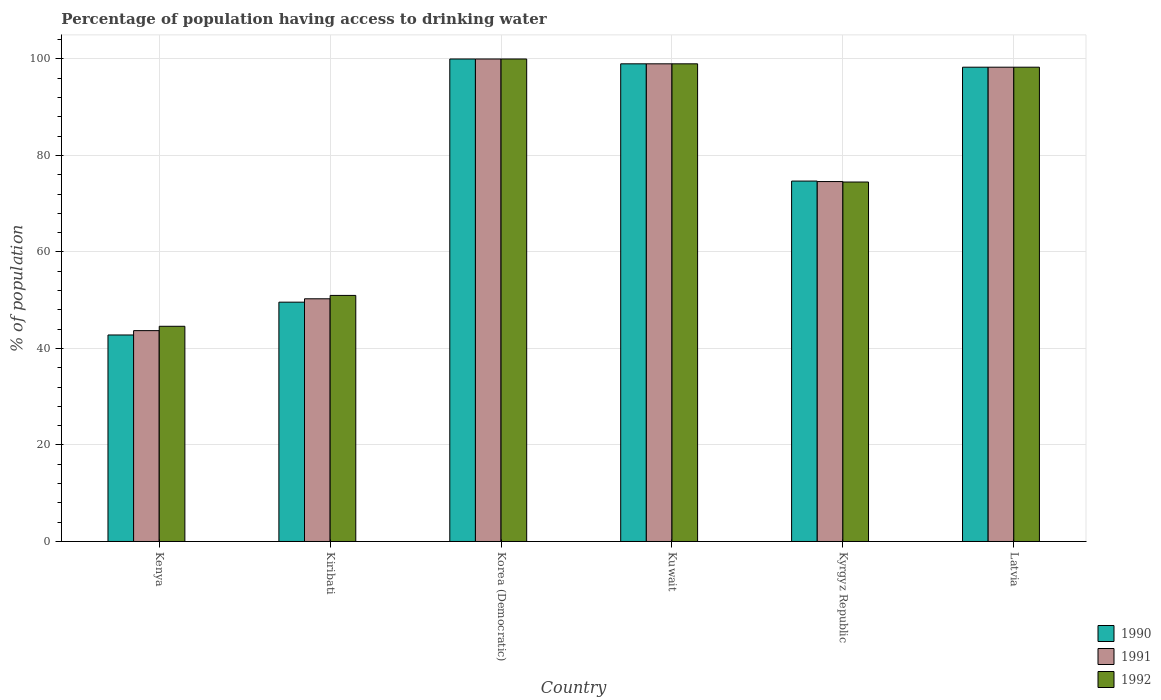How many different coloured bars are there?
Give a very brief answer. 3. Are the number of bars per tick equal to the number of legend labels?
Make the answer very short. Yes. How many bars are there on the 4th tick from the left?
Ensure brevity in your answer.  3. How many bars are there on the 1st tick from the right?
Your response must be concise. 3. What is the label of the 3rd group of bars from the left?
Your answer should be very brief. Korea (Democratic). What is the percentage of population having access to drinking water in 1992 in Kiribati?
Keep it short and to the point. 51. Across all countries, what is the minimum percentage of population having access to drinking water in 1992?
Make the answer very short. 44.6. In which country was the percentage of population having access to drinking water in 1991 maximum?
Offer a very short reply. Korea (Democratic). In which country was the percentage of population having access to drinking water in 1990 minimum?
Make the answer very short. Kenya. What is the total percentage of population having access to drinking water in 1992 in the graph?
Ensure brevity in your answer.  467.4. What is the difference between the percentage of population having access to drinking water in 1992 in Kiribati and that in Korea (Democratic)?
Ensure brevity in your answer.  -49. What is the difference between the percentage of population having access to drinking water in 1990 in Kenya and the percentage of population having access to drinking water in 1992 in Korea (Democratic)?
Offer a terse response. -57.2. What is the average percentage of population having access to drinking water in 1992 per country?
Provide a short and direct response. 77.9. What is the ratio of the percentage of population having access to drinking water in 1990 in Kiribati to that in Latvia?
Give a very brief answer. 0.5. What is the difference between the highest and the second highest percentage of population having access to drinking water in 1990?
Provide a succinct answer. -0.7. What is the difference between the highest and the lowest percentage of population having access to drinking water in 1992?
Keep it short and to the point. 55.4. Is the sum of the percentage of population having access to drinking water in 1990 in Kuwait and Kyrgyz Republic greater than the maximum percentage of population having access to drinking water in 1991 across all countries?
Keep it short and to the point. Yes. What does the 2nd bar from the left in Latvia represents?
Make the answer very short. 1991. How many bars are there?
Provide a succinct answer. 18. Does the graph contain grids?
Ensure brevity in your answer.  Yes. Where does the legend appear in the graph?
Your answer should be compact. Bottom right. How many legend labels are there?
Your answer should be very brief. 3. What is the title of the graph?
Ensure brevity in your answer.  Percentage of population having access to drinking water. What is the label or title of the X-axis?
Provide a short and direct response. Country. What is the label or title of the Y-axis?
Offer a very short reply. % of population. What is the % of population of 1990 in Kenya?
Your answer should be compact. 42.8. What is the % of population of 1991 in Kenya?
Keep it short and to the point. 43.7. What is the % of population in 1992 in Kenya?
Keep it short and to the point. 44.6. What is the % of population in 1990 in Kiribati?
Make the answer very short. 49.6. What is the % of population of 1991 in Kiribati?
Your response must be concise. 50.3. What is the % of population in 1992 in Kiribati?
Provide a short and direct response. 51. What is the % of population in 1992 in Korea (Democratic)?
Provide a short and direct response. 100. What is the % of population of 1990 in Kuwait?
Your answer should be compact. 99. What is the % of population in 1990 in Kyrgyz Republic?
Your answer should be very brief. 74.7. What is the % of population of 1991 in Kyrgyz Republic?
Offer a very short reply. 74.6. What is the % of population in 1992 in Kyrgyz Republic?
Give a very brief answer. 74.5. What is the % of population of 1990 in Latvia?
Your answer should be compact. 98.3. What is the % of population of 1991 in Latvia?
Your response must be concise. 98.3. What is the % of population in 1992 in Latvia?
Keep it short and to the point. 98.3. Across all countries, what is the maximum % of population in 1990?
Offer a very short reply. 100. Across all countries, what is the maximum % of population of 1992?
Ensure brevity in your answer.  100. Across all countries, what is the minimum % of population in 1990?
Provide a succinct answer. 42.8. Across all countries, what is the minimum % of population of 1991?
Provide a succinct answer. 43.7. Across all countries, what is the minimum % of population in 1992?
Keep it short and to the point. 44.6. What is the total % of population of 1990 in the graph?
Your answer should be very brief. 464.4. What is the total % of population of 1991 in the graph?
Give a very brief answer. 465.9. What is the total % of population of 1992 in the graph?
Make the answer very short. 467.4. What is the difference between the % of population of 1990 in Kenya and that in Kiribati?
Keep it short and to the point. -6.8. What is the difference between the % of population in 1990 in Kenya and that in Korea (Democratic)?
Make the answer very short. -57.2. What is the difference between the % of population in 1991 in Kenya and that in Korea (Democratic)?
Provide a succinct answer. -56.3. What is the difference between the % of population in 1992 in Kenya and that in Korea (Democratic)?
Your response must be concise. -55.4. What is the difference between the % of population of 1990 in Kenya and that in Kuwait?
Keep it short and to the point. -56.2. What is the difference between the % of population of 1991 in Kenya and that in Kuwait?
Your answer should be very brief. -55.3. What is the difference between the % of population of 1992 in Kenya and that in Kuwait?
Your response must be concise. -54.4. What is the difference between the % of population of 1990 in Kenya and that in Kyrgyz Republic?
Offer a very short reply. -31.9. What is the difference between the % of population of 1991 in Kenya and that in Kyrgyz Republic?
Provide a short and direct response. -30.9. What is the difference between the % of population of 1992 in Kenya and that in Kyrgyz Republic?
Make the answer very short. -29.9. What is the difference between the % of population of 1990 in Kenya and that in Latvia?
Ensure brevity in your answer.  -55.5. What is the difference between the % of population in 1991 in Kenya and that in Latvia?
Keep it short and to the point. -54.6. What is the difference between the % of population in 1992 in Kenya and that in Latvia?
Provide a succinct answer. -53.7. What is the difference between the % of population in 1990 in Kiribati and that in Korea (Democratic)?
Offer a very short reply. -50.4. What is the difference between the % of population in 1991 in Kiribati and that in Korea (Democratic)?
Provide a succinct answer. -49.7. What is the difference between the % of population in 1992 in Kiribati and that in Korea (Democratic)?
Give a very brief answer. -49. What is the difference between the % of population in 1990 in Kiribati and that in Kuwait?
Offer a very short reply. -49.4. What is the difference between the % of population of 1991 in Kiribati and that in Kuwait?
Your response must be concise. -48.7. What is the difference between the % of population in 1992 in Kiribati and that in Kuwait?
Offer a terse response. -48. What is the difference between the % of population in 1990 in Kiribati and that in Kyrgyz Republic?
Ensure brevity in your answer.  -25.1. What is the difference between the % of population of 1991 in Kiribati and that in Kyrgyz Republic?
Offer a terse response. -24.3. What is the difference between the % of population in 1992 in Kiribati and that in Kyrgyz Republic?
Provide a short and direct response. -23.5. What is the difference between the % of population in 1990 in Kiribati and that in Latvia?
Your answer should be compact. -48.7. What is the difference between the % of population in 1991 in Kiribati and that in Latvia?
Offer a terse response. -48. What is the difference between the % of population of 1992 in Kiribati and that in Latvia?
Offer a very short reply. -47.3. What is the difference between the % of population of 1991 in Korea (Democratic) and that in Kuwait?
Offer a terse response. 1. What is the difference between the % of population in 1990 in Korea (Democratic) and that in Kyrgyz Republic?
Keep it short and to the point. 25.3. What is the difference between the % of population of 1991 in Korea (Democratic) and that in Kyrgyz Republic?
Your response must be concise. 25.4. What is the difference between the % of population of 1992 in Korea (Democratic) and that in Kyrgyz Republic?
Provide a short and direct response. 25.5. What is the difference between the % of population in 1991 in Korea (Democratic) and that in Latvia?
Your response must be concise. 1.7. What is the difference between the % of population in 1992 in Korea (Democratic) and that in Latvia?
Make the answer very short. 1.7. What is the difference between the % of population in 1990 in Kuwait and that in Kyrgyz Republic?
Offer a terse response. 24.3. What is the difference between the % of population in 1991 in Kuwait and that in Kyrgyz Republic?
Make the answer very short. 24.4. What is the difference between the % of population of 1992 in Kuwait and that in Kyrgyz Republic?
Ensure brevity in your answer.  24.5. What is the difference between the % of population of 1991 in Kuwait and that in Latvia?
Offer a very short reply. 0.7. What is the difference between the % of population of 1990 in Kyrgyz Republic and that in Latvia?
Keep it short and to the point. -23.6. What is the difference between the % of population of 1991 in Kyrgyz Republic and that in Latvia?
Provide a short and direct response. -23.7. What is the difference between the % of population of 1992 in Kyrgyz Republic and that in Latvia?
Keep it short and to the point. -23.8. What is the difference between the % of population of 1990 in Kenya and the % of population of 1991 in Kiribati?
Keep it short and to the point. -7.5. What is the difference between the % of population of 1990 in Kenya and the % of population of 1991 in Korea (Democratic)?
Make the answer very short. -57.2. What is the difference between the % of population of 1990 in Kenya and the % of population of 1992 in Korea (Democratic)?
Your answer should be very brief. -57.2. What is the difference between the % of population of 1991 in Kenya and the % of population of 1992 in Korea (Democratic)?
Provide a succinct answer. -56.3. What is the difference between the % of population in 1990 in Kenya and the % of population in 1991 in Kuwait?
Give a very brief answer. -56.2. What is the difference between the % of population of 1990 in Kenya and the % of population of 1992 in Kuwait?
Your answer should be compact. -56.2. What is the difference between the % of population in 1991 in Kenya and the % of population in 1992 in Kuwait?
Make the answer very short. -55.3. What is the difference between the % of population in 1990 in Kenya and the % of population in 1991 in Kyrgyz Republic?
Offer a very short reply. -31.8. What is the difference between the % of population of 1990 in Kenya and the % of population of 1992 in Kyrgyz Republic?
Keep it short and to the point. -31.7. What is the difference between the % of population in 1991 in Kenya and the % of population in 1992 in Kyrgyz Republic?
Your response must be concise. -30.8. What is the difference between the % of population of 1990 in Kenya and the % of population of 1991 in Latvia?
Offer a terse response. -55.5. What is the difference between the % of population in 1990 in Kenya and the % of population in 1992 in Latvia?
Keep it short and to the point. -55.5. What is the difference between the % of population of 1991 in Kenya and the % of population of 1992 in Latvia?
Your answer should be very brief. -54.6. What is the difference between the % of population in 1990 in Kiribati and the % of population in 1991 in Korea (Democratic)?
Provide a short and direct response. -50.4. What is the difference between the % of population in 1990 in Kiribati and the % of population in 1992 in Korea (Democratic)?
Offer a very short reply. -50.4. What is the difference between the % of population of 1991 in Kiribati and the % of population of 1992 in Korea (Democratic)?
Ensure brevity in your answer.  -49.7. What is the difference between the % of population of 1990 in Kiribati and the % of population of 1991 in Kuwait?
Ensure brevity in your answer.  -49.4. What is the difference between the % of population of 1990 in Kiribati and the % of population of 1992 in Kuwait?
Your answer should be very brief. -49.4. What is the difference between the % of population in 1991 in Kiribati and the % of population in 1992 in Kuwait?
Provide a short and direct response. -48.7. What is the difference between the % of population in 1990 in Kiribati and the % of population in 1992 in Kyrgyz Republic?
Keep it short and to the point. -24.9. What is the difference between the % of population of 1991 in Kiribati and the % of population of 1992 in Kyrgyz Republic?
Your answer should be compact. -24.2. What is the difference between the % of population in 1990 in Kiribati and the % of population in 1991 in Latvia?
Offer a very short reply. -48.7. What is the difference between the % of population of 1990 in Kiribati and the % of population of 1992 in Latvia?
Make the answer very short. -48.7. What is the difference between the % of population of 1991 in Kiribati and the % of population of 1992 in Latvia?
Keep it short and to the point. -48. What is the difference between the % of population of 1990 in Korea (Democratic) and the % of population of 1991 in Kuwait?
Make the answer very short. 1. What is the difference between the % of population in 1991 in Korea (Democratic) and the % of population in 1992 in Kuwait?
Offer a terse response. 1. What is the difference between the % of population of 1990 in Korea (Democratic) and the % of population of 1991 in Kyrgyz Republic?
Provide a succinct answer. 25.4. What is the difference between the % of population in 1991 in Korea (Democratic) and the % of population in 1992 in Kyrgyz Republic?
Give a very brief answer. 25.5. What is the difference between the % of population of 1990 in Korea (Democratic) and the % of population of 1991 in Latvia?
Make the answer very short. 1.7. What is the difference between the % of population of 1991 in Korea (Democratic) and the % of population of 1992 in Latvia?
Offer a very short reply. 1.7. What is the difference between the % of population in 1990 in Kuwait and the % of population in 1991 in Kyrgyz Republic?
Your answer should be very brief. 24.4. What is the difference between the % of population in 1990 in Kuwait and the % of population in 1992 in Kyrgyz Republic?
Make the answer very short. 24.5. What is the difference between the % of population of 1991 in Kuwait and the % of population of 1992 in Kyrgyz Republic?
Offer a very short reply. 24.5. What is the difference between the % of population of 1990 in Kyrgyz Republic and the % of population of 1991 in Latvia?
Your response must be concise. -23.6. What is the difference between the % of population of 1990 in Kyrgyz Republic and the % of population of 1992 in Latvia?
Offer a terse response. -23.6. What is the difference between the % of population in 1991 in Kyrgyz Republic and the % of population in 1992 in Latvia?
Ensure brevity in your answer.  -23.7. What is the average % of population of 1990 per country?
Make the answer very short. 77.4. What is the average % of population in 1991 per country?
Keep it short and to the point. 77.65. What is the average % of population in 1992 per country?
Your response must be concise. 77.9. What is the difference between the % of population in 1991 and % of population in 1992 in Kenya?
Make the answer very short. -0.9. What is the difference between the % of population in 1990 and % of population in 1992 in Kiribati?
Your answer should be compact. -1.4. What is the difference between the % of population of 1991 and % of population of 1992 in Kiribati?
Provide a short and direct response. -0.7. What is the difference between the % of population in 1990 and % of population in 1991 in Korea (Democratic)?
Your response must be concise. 0. What is the difference between the % of population in 1991 and % of population in 1992 in Kuwait?
Provide a succinct answer. 0. What is the difference between the % of population in 1990 and % of population in 1992 in Kyrgyz Republic?
Your response must be concise. 0.2. What is the difference between the % of population in 1990 and % of population in 1991 in Latvia?
Offer a very short reply. 0. What is the ratio of the % of population in 1990 in Kenya to that in Kiribati?
Offer a very short reply. 0.86. What is the ratio of the % of population of 1991 in Kenya to that in Kiribati?
Your response must be concise. 0.87. What is the ratio of the % of population of 1992 in Kenya to that in Kiribati?
Your answer should be compact. 0.87. What is the ratio of the % of population of 1990 in Kenya to that in Korea (Democratic)?
Give a very brief answer. 0.43. What is the ratio of the % of population in 1991 in Kenya to that in Korea (Democratic)?
Offer a very short reply. 0.44. What is the ratio of the % of population in 1992 in Kenya to that in Korea (Democratic)?
Provide a succinct answer. 0.45. What is the ratio of the % of population in 1990 in Kenya to that in Kuwait?
Your answer should be very brief. 0.43. What is the ratio of the % of population of 1991 in Kenya to that in Kuwait?
Make the answer very short. 0.44. What is the ratio of the % of population of 1992 in Kenya to that in Kuwait?
Give a very brief answer. 0.45. What is the ratio of the % of population of 1990 in Kenya to that in Kyrgyz Republic?
Give a very brief answer. 0.57. What is the ratio of the % of population of 1991 in Kenya to that in Kyrgyz Republic?
Make the answer very short. 0.59. What is the ratio of the % of population of 1992 in Kenya to that in Kyrgyz Republic?
Keep it short and to the point. 0.6. What is the ratio of the % of population in 1990 in Kenya to that in Latvia?
Your answer should be very brief. 0.44. What is the ratio of the % of population of 1991 in Kenya to that in Latvia?
Ensure brevity in your answer.  0.44. What is the ratio of the % of population in 1992 in Kenya to that in Latvia?
Your response must be concise. 0.45. What is the ratio of the % of population in 1990 in Kiribati to that in Korea (Democratic)?
Ensure brevity in your answer.  0.5. What is the ratio of the % of population of 1991 in Kiribati to that in Korea (Democratic)?
Make the answer very short. 0.5. What is the ratio of the % of population in 1992 in Kiribati to that in Korea (Democratic)?
Your response must be concise. 0.51. What is the ratio of the % of population in 1990 in Kiribati to that in Kuwait?
Keep it short and to the point. 0.5. What is the ratio of the % of population in 1991 in Kiribati to that in Kuwait?
Your answer should be very brief. 0.51. What is the ratio of the % of population of 1992 in Kiribati to that in Kuwait?
Your response must be concise. 0.52. What is the ratio of the % of population of 1990 in Kiribati to that in Kyrgyz Republic?
Offer a very short reply. 0.66. What is the ratio of the % of population of 1991 in Kiribati to that in Kyrgyz Republic?
Your answer should be very brief. 0.67. What is the ratio of the % of population of 1992 in Kiribati to that in Kyrgyz Republic?
Provide a short and direct response. 0.68. What is the ratio of the % of population of 1990 in Kiribati to that in Latvia?
Provide a short and direct response. 0.5. What is the ratio of the % of population in 1991 in Kiribati to that in Latvia?
Your answer should be very brief. 0.51. What is the ratio of the % of population of 1992 in Kiribati to that in Latvia?
Provide a succinct answer. 0.52. What is the ratio of the % of population of 1990 in Korea (Democratic) to that in Kuwait?
Your answer should be very brief. 1.01. What is the ratio of the % of population of 1992 in Korea (Democratic) to that in Kuwait?
Give a very brief answer. 1.01. What is the ratio of the % of population in 1990 in Korea (Democratic) to that in Kyrgyz Republic?
Your response must be concise. 1.34. What is the ratio of the % of population in 1991 in Korea (Democratic) to that in Kyrgyz Republic?
Keep it short and to the point. 1.34. What is the ratio of the % of population in 1992 in Korea (Democratic) to that in Kyrgyz Republic?
Your answer should be compact. 1.34. What is the ratio of the % of population of 1990 in Korea (Democratic) to that in Latvia?
Your response must be concise. 1.02. What is the ratio of the % of population in 1991 in Korea (Democratic) to that in Latvia?
Your answer should be compact. 1.02. What is the ratio of the % of population in 1992 in Korea (Democratic) to that in Latvia?
Keep it short and to the point. 1.02. What is the ratio of the % of population in 1990 in Kuwait to that in Kyrgyz Republic?
Make the answer very short. 1.33. What is the ratio of the % of population of 1991 in Kuwait to that in Kyrgyz Republic?
Provide a short and direct response. 1.33. What is the ratio of the % of population of 1992 in Kuwait to that in Kyrgyz Republic?
Give a very brief answer. 1.33. What is the ratio of the % of population of 1990 in Kuwait to that in Latvia?
Offer a very short reply. 1.01. What is the ratio of the % of population in 1991 in Kuwait to that in Latvia?
Keep it short and to the point. 1.01. What is the ratio of the % of population in 1992 in Kuwait to that in Latvia?
Make the answer very short. 1.01. What is the ratio of the % of population of 1990 in Kyrgyz Republic to that in Latvia?
Make the answer very short. 0.76. What is the ratio of the % of population of 1991 in Kyrgyz Republic to that in Latvia?
Ensure brevity in your answer.  0.76. What is the ratio of the % of population in 1992 in Kyrgyz Republic to that in Latvia?
Your answer should be very brief. 0.76. What is the difference between the highest and the second highest % of population of 1990?
Provide a succinct answer. 1. What is the difference between the highest and the second highest % of population of 1992?
Your answer should be very brief. 1. What is the difference between the highest and the lowest % of population of 1990?
Your answer should be very brief. 57.2. What is the difference between the highest and the lowest % of population in 1991?
Your answer should be compact. 56.3. What is the difference between the highest and the lowest % of population in 1992?
Provide a short and direct response. 55.4. 